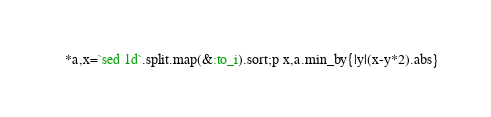<code> <loc_0><loc_0><loc_500><loc_500><_Ruby_>*a,x=`sed 1d`.split.map(&:to_i).sort;p x,a.min_by{|y|(x-y*2).abs}</code> 